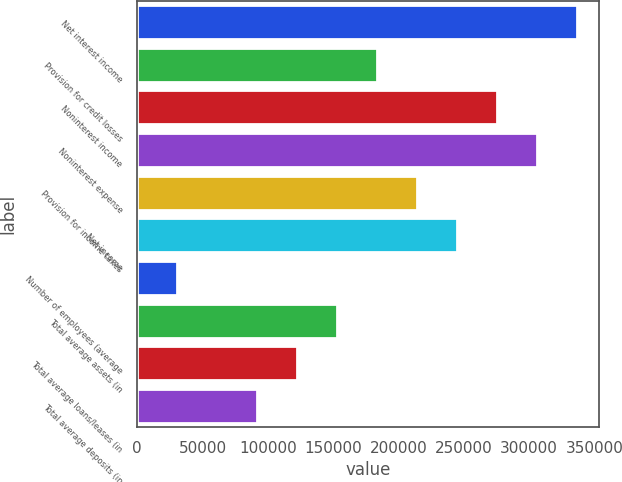Convert chart to OTSL. <chart><loc_0><loc_0><loc_500><loc_500><bar_chart><fcel>Net interest income<fcel>Provision for credit losses<fcel>Noninterest income<fcel>Noninterest expense<fcel>Provision for income taxes<fcel>Net income<fcel>Number of employees (average<fcel>Total average assets (in<fcel>Total average loans/leases (in<fcel>Total average deposits (in<nl><fcel>337077<fcel>183861<fcel>275791<fcel>306434<fcel>214505<fcel>245148<fcel>30645.7<fcel>153218<fcel>122575<fcel>91932<nl></chart> 